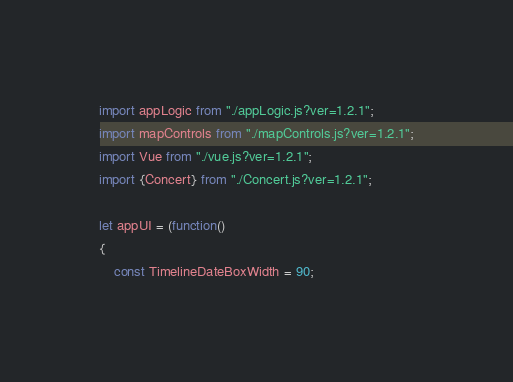<code> <loc_0><loc_0><loc_500><loc_500><_JavaScript_>import appLogic from "./appLogic.js?ver=1.2.1";
import mapControls from "./mapControls.js?ver=1.2.1";
import Vue from "./vue.js?ver=1.2.1";
import {Concert} from "./Concert.js?ver=1.2.1";

let appUI = (function()
{
	const TimelineDateBoxWidth = 90;</code> 